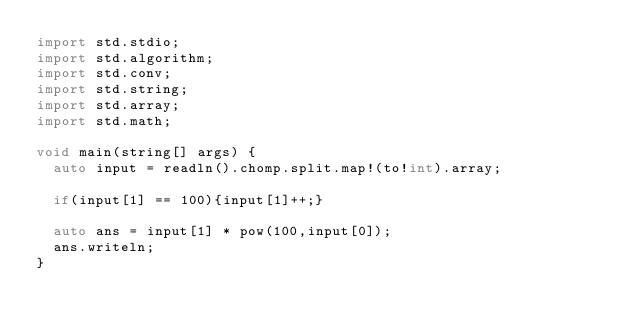<code> <loc_0><loc_0><loc_500><loc_500><_D_>import std.stdio;
import std.algorithm;
import std.conv;
import std.string;
import std.array;
import std.math;

void main(string[] args) {
  auto input = readln().chomp.split.map!(to!int).array;

  if(input[1] == 100){input[1]++;}

  auto ans = input[1] * pow(100,input[0]);
  ans.writeln;
}</code> 